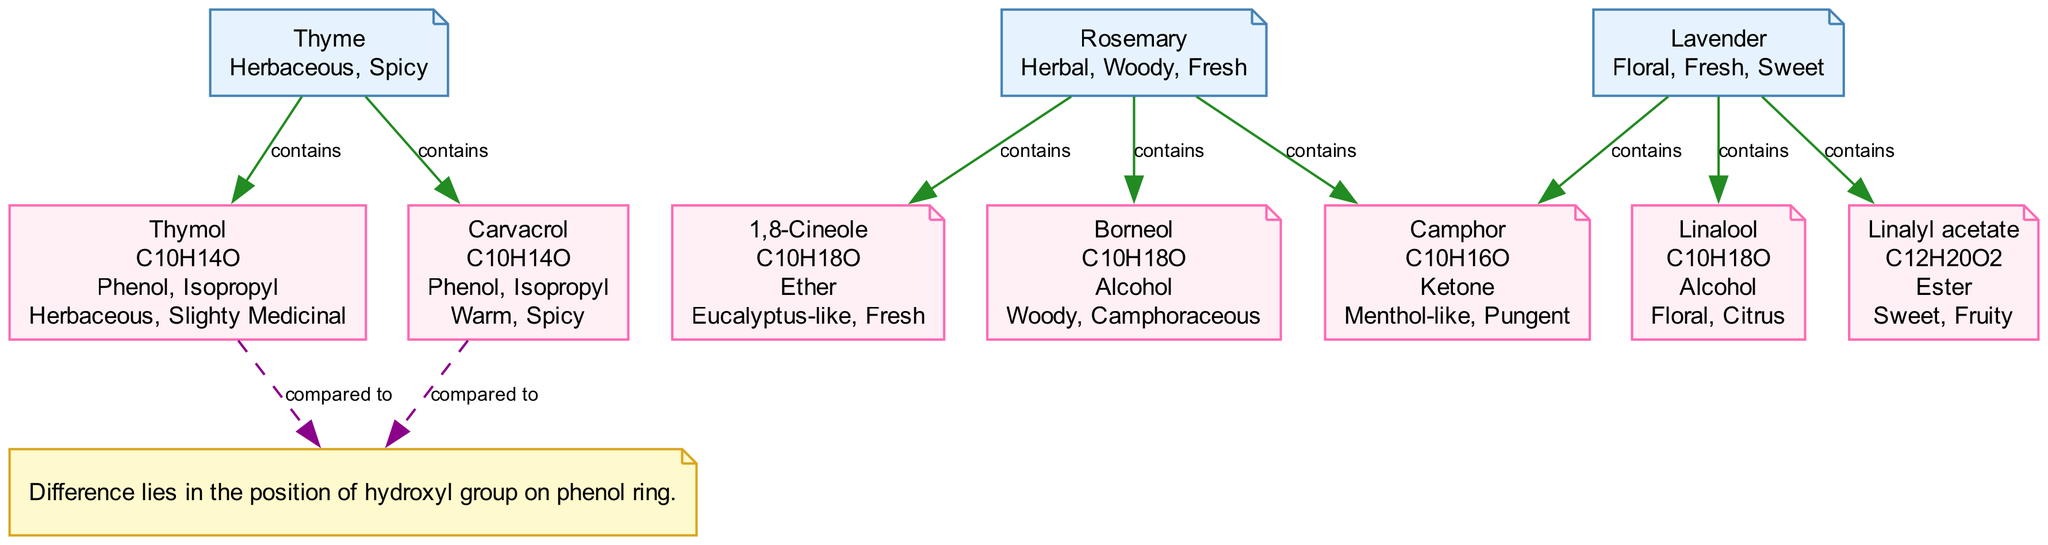What compounds are found in lavender? In the diagram, the lavender node connects to three compounds: Linalool, Linalyl acetate, and Camphor, which are displayed directly under the lavender node.
Answer: Linalool, Linalyl acetate, Camphor What aroma profile is associated with rosemary? The rosemary node has an aroma profile associated with it, which is indicated in the diagram next to the rosemary label. The aroma profiles listed are Herbal, Woody, and Fresh.
Answer: Herbal, Woody, Fresh How many aromatic compounds are listed in total? By counting all the compounds across the botanical nodes, specifically in thyme, rosemary, and lavender, we find a total of six compounds: Thymol, Carvacrol, 1,8-Cineole, Camphor, Borneol, Linalool, and Linalyl acetate.
Answer: Six What is the difference between Thymol and Carvacrol? The difference is specifically labeled in the diagram, showing a text node connected to both Thymol and Carvacrol, stating that "Difference lies in the position of hydroxyl group on phenol ring."
Answer: Position of hydroxyl group Which compound has a structure of C10H18O? 1,8-Cineole and Borneol both have a structure of C10H18O, as indicated in the structure lines of their respective node descriptions in the diagram.
Answer: 1,8-Cineole, Borneol What functional group does Carvacrol belong to? Carvacrol has a label in the diagram that indicates it has functional groups. By examining the node for Carvacrol, we see it is labeled as having the functional groups Phenol and Isopropyl.
Answer: Phenol, Isopropyl Which compound is described as having a menthol-like aroma? In the diagram, the Camphor node specifically lists its aroma profiles, which includes the description "Menthol-like," directly answering the question about its aroma.
Answer: Menthol-like How many components are listed under thyme? The thyme node connects to two components: Thymol and Carvacrol, which are indicated directly below the thyme node, making it straightforward to count the components.
Answer: Two 